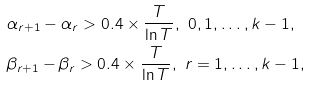<formula> <loc_0><loc_0><loc_500><loc_500>& \alpha _ { r + 1 } - \alpha _ { r } > 0 . 4 \times \frac { T } { \ln T } , \ 0 , 1 , \dots , k - 1 , \\ & \beta _ { r + 1 } - \beta _ { r } > 0 . 4 \times \frac { T } { \ln T } , \ r = 1 , \dots , k - 1 ,</formula> 